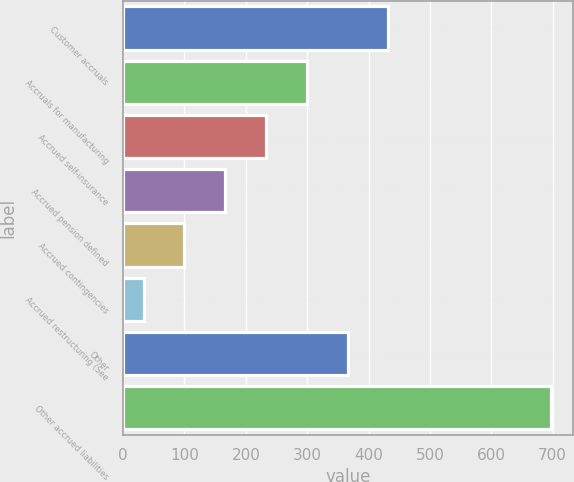Convert chart. <chart><loc_0><loc_0><loc_500><loc_500><bar_chart><fcel>Customer accruals<fcel>Accruals for manufacturing<fcel>Accrued self-insurance<fcel>Accrued pension defined<fcel>Accrued contingencies<fcel>Accrued restructuring (See<fcel>Other<fcel>Other accrued liabilities<nl><fcel>432.32<fcel>299.38<fcel>232.91<fcel>166.44<fcel>99.97<fcel>33.5<fcel>365.85<fcel>698.2<nl></chart> 